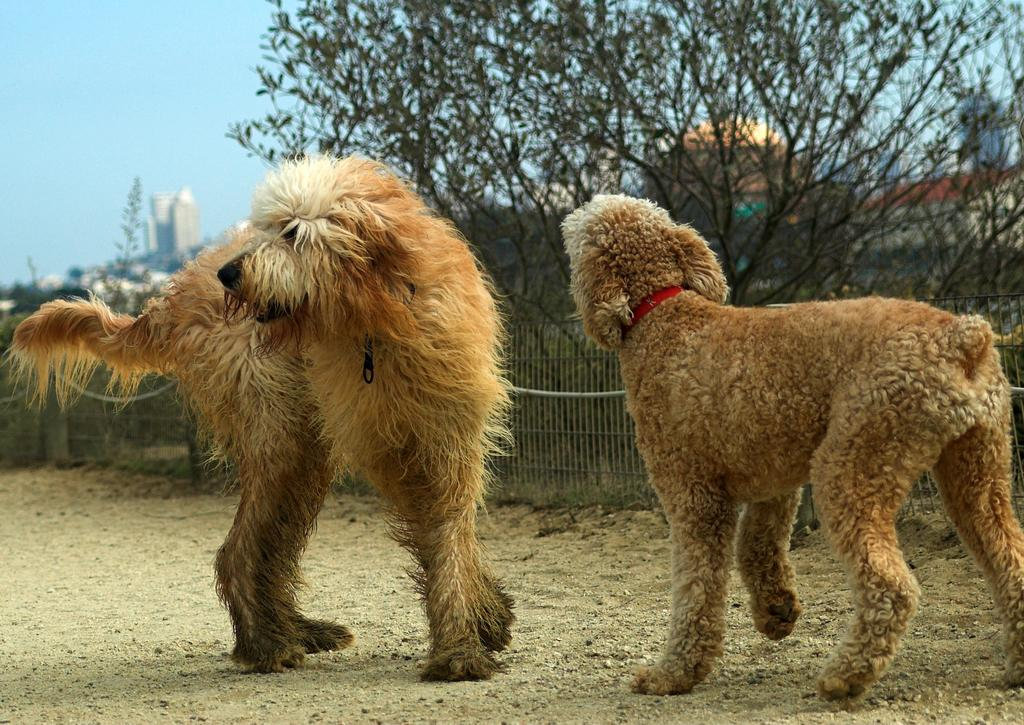What animals are present in the image? There are dogs standing on the ground in the image. What is the main object visible in the image? There is a grill visible in the image. What type of natural vegetation can be seen in the image? There are trees in the image. What type of man-made structures can be seen in the image? There are buildings in the image. What part of the natural environment is visible in the image? The sky is visible in the image. Can you see any islands in the image? There is no island present in the image. What type of sail can be seen on the dogs in the image? There are no sails present in the image, and the dogs are not wearing any sails. 